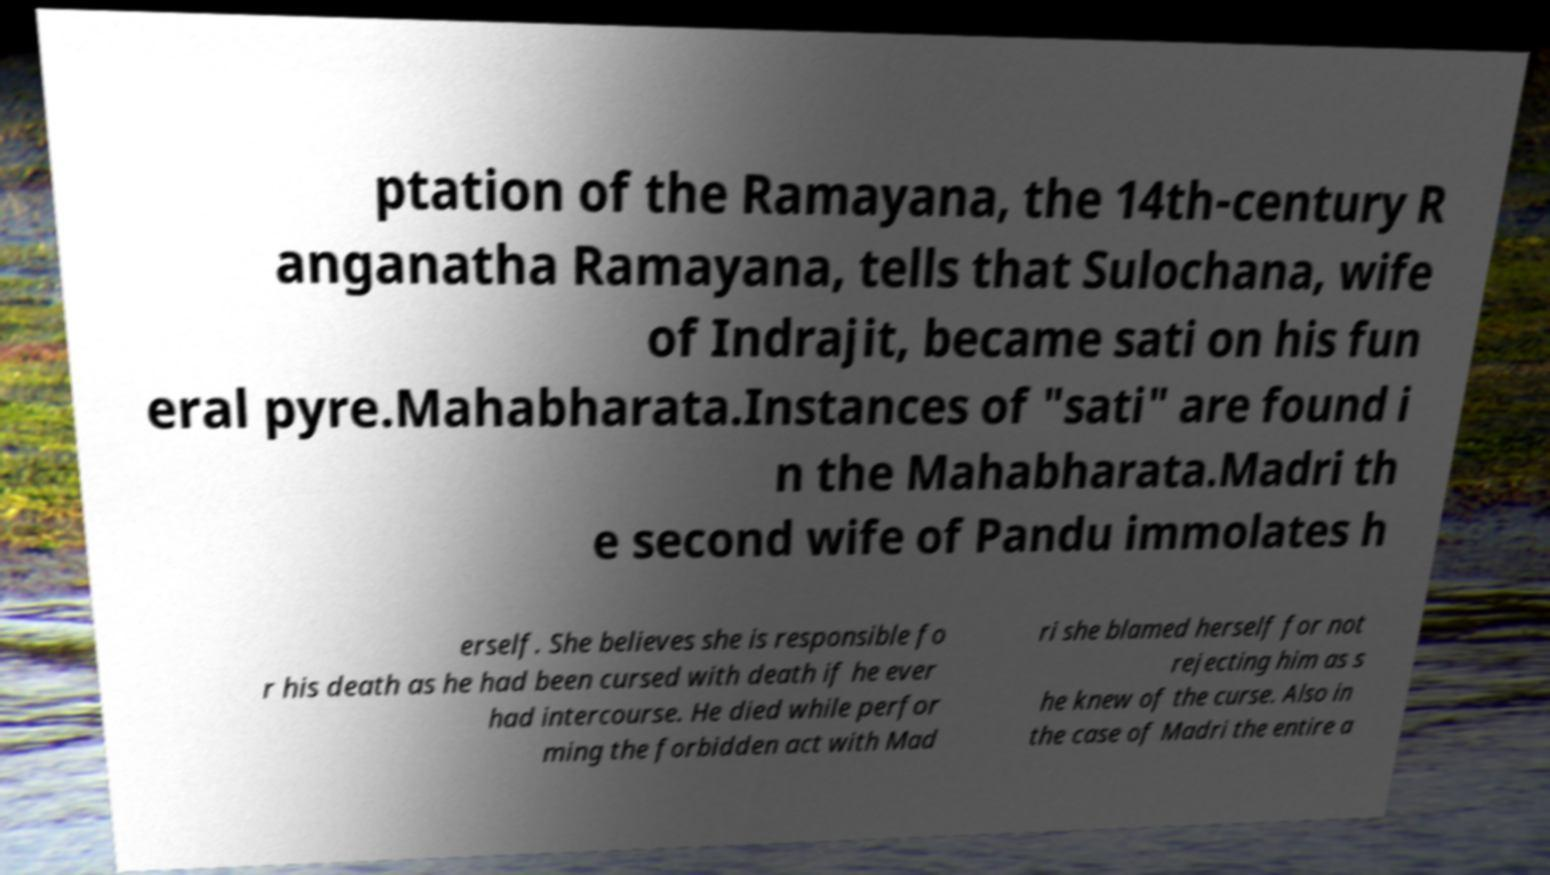I need the written content from this picture converted into text. Can you do that? ptation of the Ramayana, the 14th-century R anganatha Ramayana, tells that Sulochana, wife of Indrajit, became sati on his fun eral pyre.Mahabharata.Instances of "sati" are found i n the Mahabharata.Madri th e second wife of Pandu immolates h erself. She believes she is responsible fo r his death as he had been cursed with death if he ever had intercourse. He died while perfor ming the forbidden act with Mad ri she blamed herself for not rejecting him as s he knew of the curse. Also in the case of Madri the entire a 